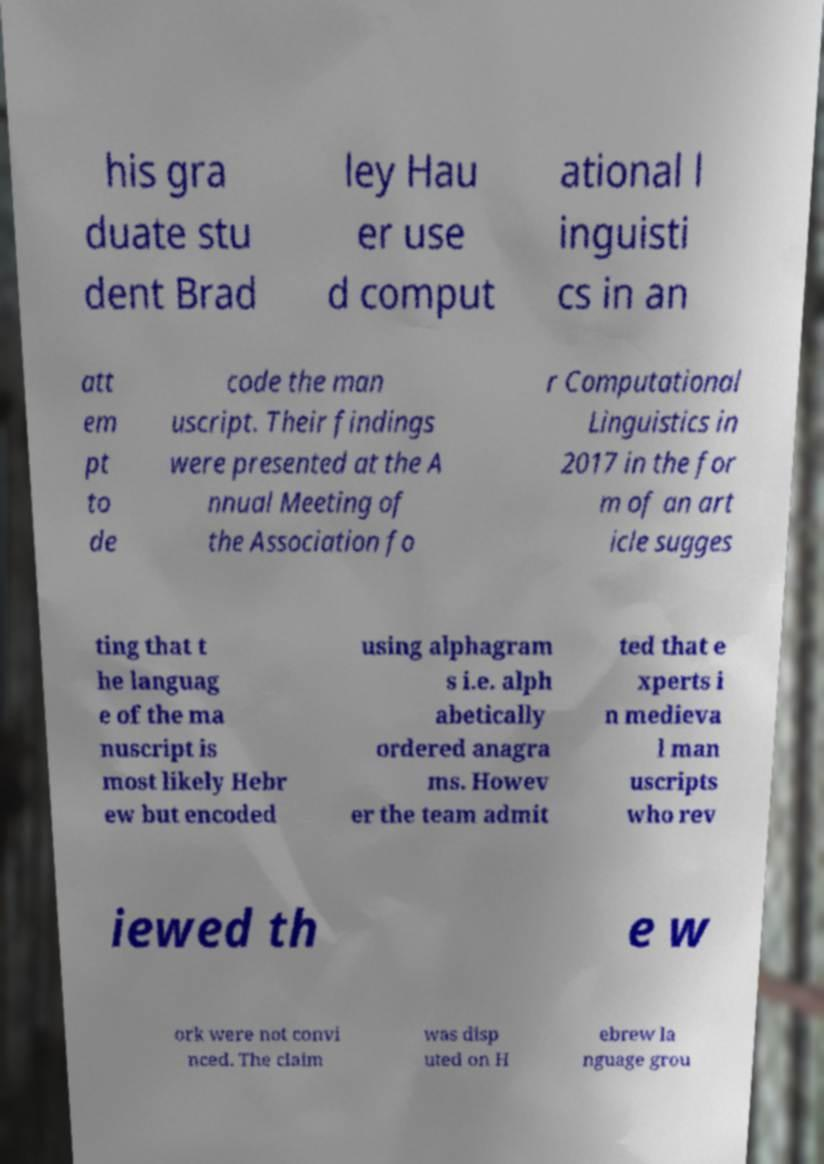Can you read and provide the text displayed in the image?This photo seems to have some interesting text. Can you extract and type it out for me? his gra duate stu dent Brad ley Hau er use d comput ational l inguisti cs in an att em pt to de code the man uscript. Their findings were presented at the A nnual Meeting of the Association fo r Computational Linguistics in 2017 in the for m of an art icle sugges ting that t he languag e of the ma nuscript is most likely Hebr ew but encoded using alphagram s i.e. alph abetically ordered anagra ms. Howev er the team admit ted that e xperts i n medieva l man uscripts who rev iewed th e w ork were not convi nced. The claim was disp uted on H ebrew la nguage grou 